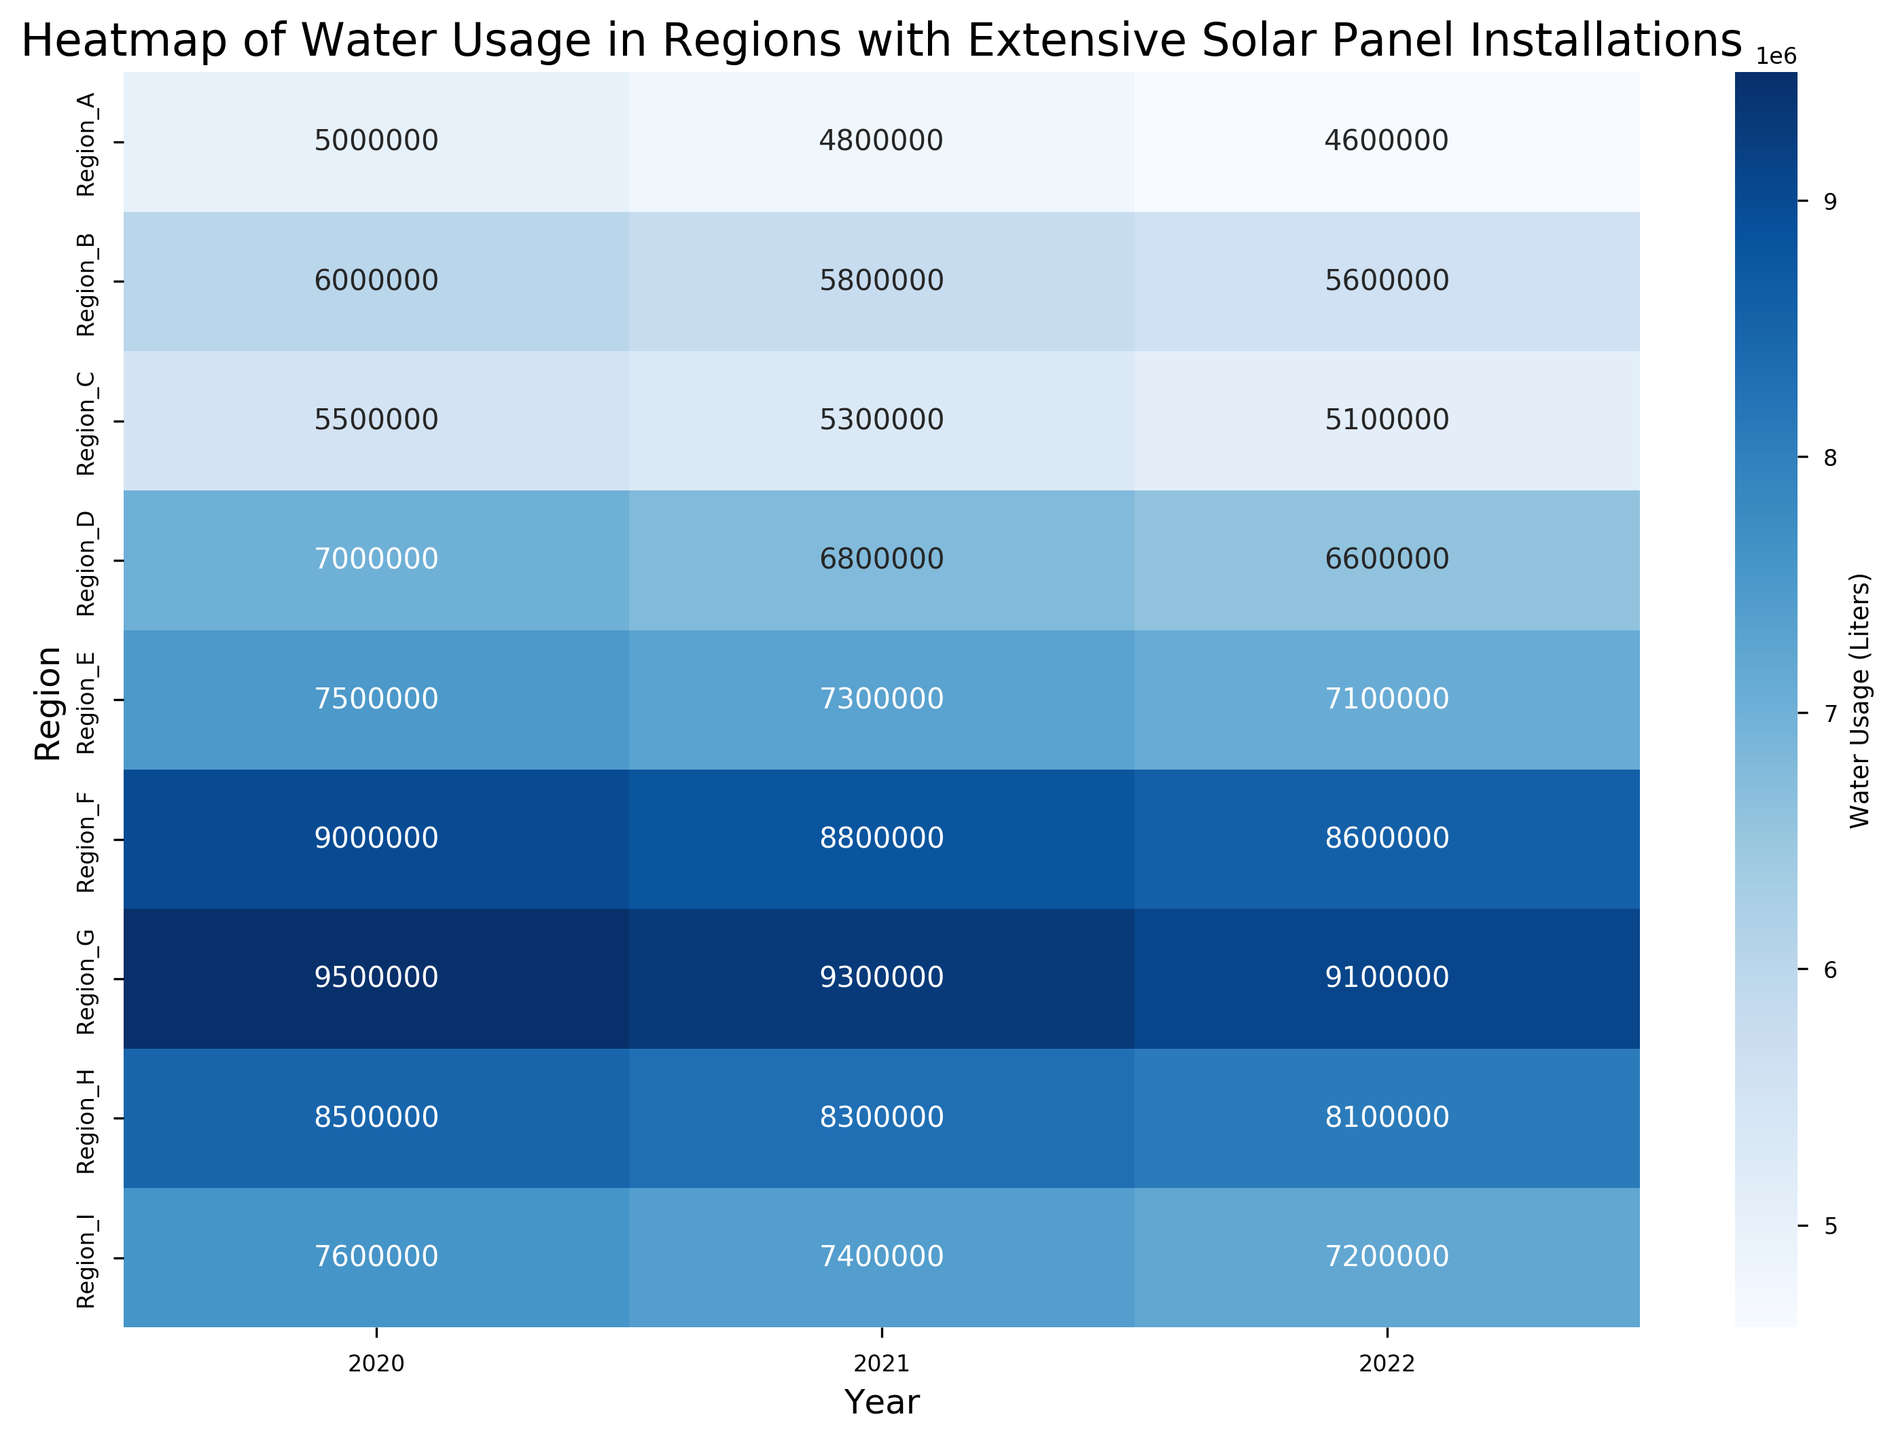What is the water usage in Region_A for the year 2021? Locate the intersection of Region_A and 2021 on the heatmap to find the water usage value.
Answer: 4,800,000 liters Which region had the highest water usage in any year? Identify the darkest blue cell in the heatmap, which indicates the highest water usage value.
Answer: Region_G in 2020 What is the difference in water usage between Region_B and Region_D in 2022? Find the water usage for Region_B in 2022 and Region_D in 2022, then subtract the smaller value from the larger one. (5,600,000 - 6,600,000)
Answer: 1,000,000 liters Which year had the lowest water usage for Region_H? Compare the water usage values for Region_H across all years and identify the smallest value.
Answer: 2022 Which two regions had the closest water usage values in 2020? Compare the water usage values for all regions in 2020 and identify the two regions with the closest numerical values.
Answer: Region_E and Region_I What is the average water usage across all regions in 2021? Sum the water usage values for all regions in 2021 and divide by the number of regions (10). (48,000,000 / 10)
Answer: 7,400,000 liters How much did the water usage in Region_C decrease from 2020 to 2022? Subtract the water usage value in 2022 from the value in 2020 for Region_C. (5,500,000 - 5,100,000)
Answer: 400,000 liters What general trend is visible in the water usage for Region_F across the years? Examine the variation in color shades for Region_F across the years to describe the trend.
Answer: Decreasing trend 